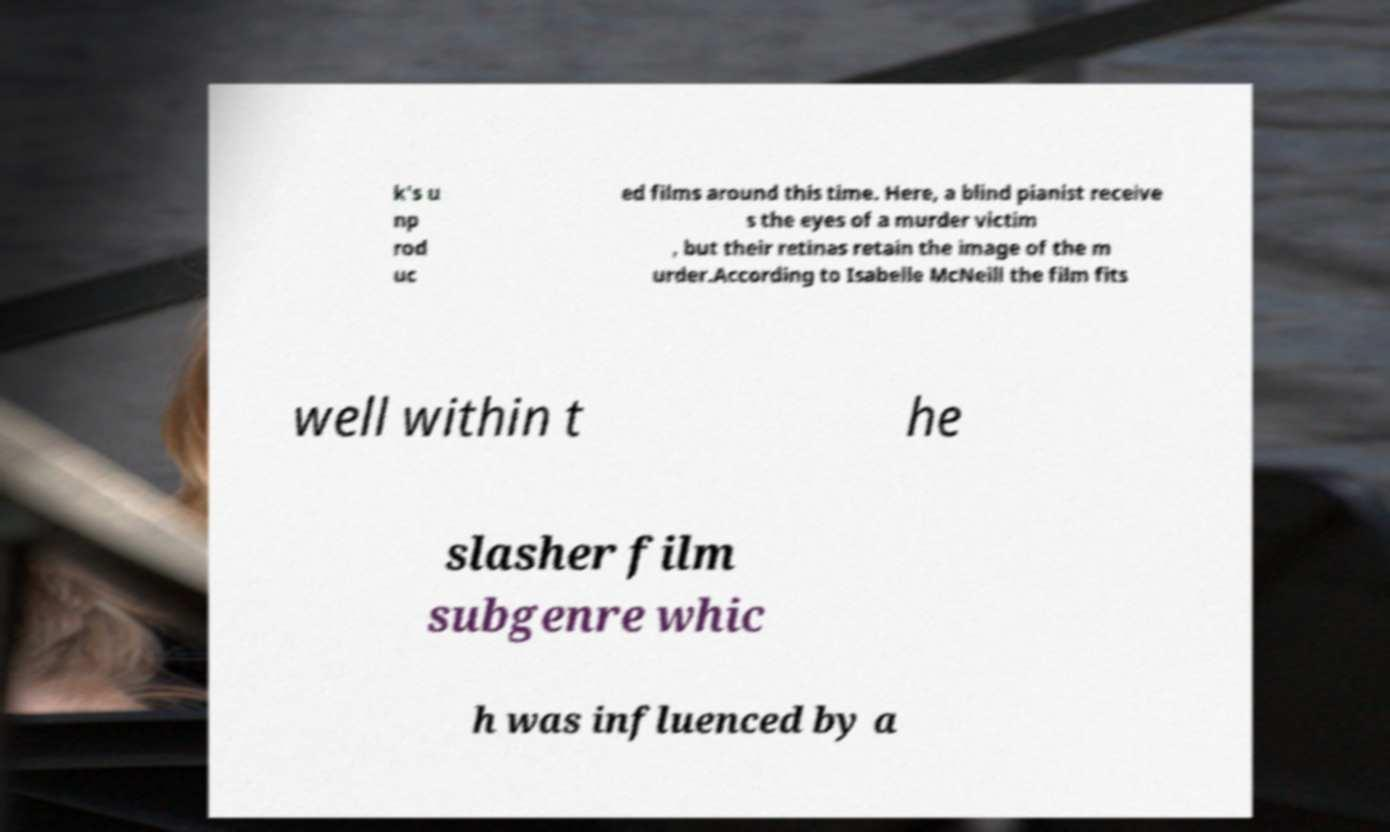Please read and relay the text visible in this image. What does it say? k's u np rod uc ed films around this time. Here, a blind pianist receive s the eyes of a murder victim , but their retinas retain the image of the m urder.According to Isabelle McNeill the film fits well within t he slasher film subgenre whic h was influenced by a 